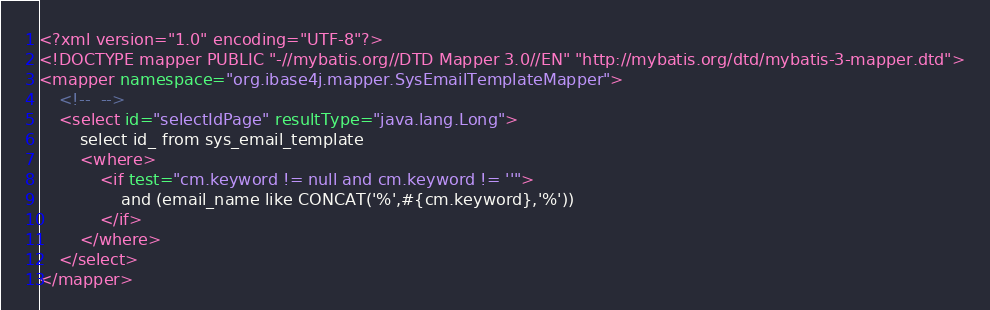<code> <loc_0><loc_0><loc_500><loc_500><_XML_><?xml version="1.0" encoding="UTF-8"?>
<!DOCTYPE mapper PUBLIC "-//mybatis.org//DTD Mapper 3.0//EN" "http://mybatis.org/dtd/mybatis-3-mapper.dtd">
<mapper namespace="org.ibase4j.mapper.SysEmailTemplateMapper">
	<!--  -->
	<select id="selectIdPage" resultType="java.lang.Long">
		select id_ from sys_email_template
		<where>
			<if test="cm.keyword != null and cm.keyword != ''">
				and (email_name like CONCAT('%',#{cm.keyword},'%'))
			</if>
		</where>
	</select>
</mapper>
</code> 